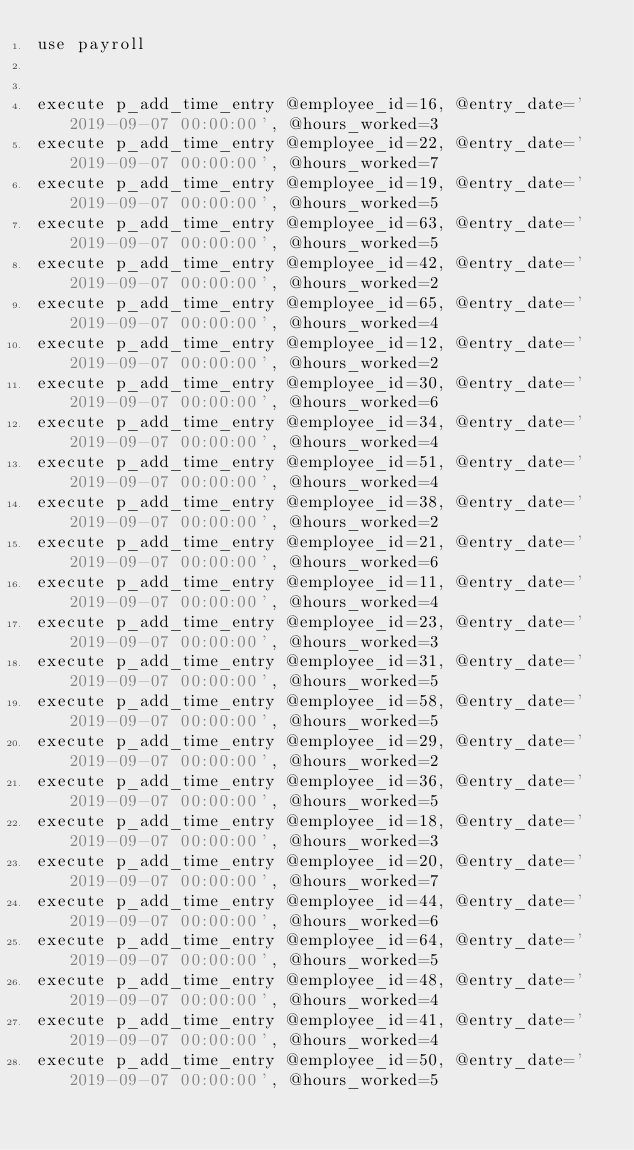<code> <loc_0><loc_0><loc_500><loc_500><_SQL_>use payroll


execute p_add_time_entry @employee_id=16, @entry_date='2019-09-07 00:00:00', @hours_worked=3
execute p_add_time_entry @employee_id=22, @entry_date='2019-09-07 00:00:00', @hours_worked=7
execute p_add_time_entry @employee_id=19, @entry_date='2019-09-07 00:00:00', @hours_worked=5
execute p_add_time_entry @employee_id=63, @entry_date='2019-09-07 00:00:00', @hours_worked=5
execute p_add_time_entry @employee_id=42, @entry_date='2019-09-07 00:00:00', @hours_worked=2
execute p_add_time_entry @employee_id=65, @entry_date='2019-09-07 00:00:00', @hours_worked=4
execute p_add_time_entry @employee_id=12, @entry_date='2019-09-07 00:00:00', @hours_worked=2
execute p_add_time_entry @employee_id=30, @entry_date='2019-09-07 00:00:00', @hours_worked=6
execute p_add_time_entry @employee_id=34, @entry_date='2019-09-07 00:00:00', @hours_worked=4
execute p_add_time_entry @employee_id=51, @entry_date='2019-09-07 00:00:00', @hours_worked=4
execute p_add_time_entry @employee_id=38, @entry_date='2019-09-07 00:00:00', @hours_worked=2
execute p_add_time_entry @employee_id=21, @entry_date='2019-09-07 00:00:00', @hours_worked=6
execute p_add_time_entry @employee_id=11, @entry_date='2019-09-07 00:00:00', @hours_worked=4
execute p_add_time_entry @employee_id=23, @entry_date='2019-09-07 00:00:00', @hours_worked=3
execute p_add_time_entry @employee_id=31, @entry_date='2019-09-07 00:00:00', @hours_worked=5
execute p_add_time_entry @employee_id=58, @entry_date='2019-09-07 00:00:00', @hours_worked=5
execute p_add_time_entry @employee_id=29, @entry_date='2019-09-07 00:00:00', @hours_worked=2
execute p_add_time_entry @employee_id=36, @entry_date='2019-09-07 00:00:00', @hours_worked=5
execute p_add_time_entry @employee_id=18, @entry_date='2019-09-07 00:00:00', @hours_worked=3
execute p_add_time_entry @employee_id=20, @entry_date='2019-09-07 00:00:00', @hours_worked=7
execute p_add_time_entry @employee_id=44, @entry_date='2019-09-07 00:00:00', @hours_worked=6
execute p_add_time_entry @employee_id=64, @entry_date='2019-09-07 00:00:00', @hours_worked=5
execute p_add_time_entry @employee_id=48, @entry_date='2019-09-07 00:00:00', @hours_worked=4
execute p_add_time_entry @employee_id=41, @entry_date='2019-09-07 00:00:00', @hours_worked=4
execute p_add_time_entry @employee_id=50, @entry_date='2019-09-07 00:00:00', @hours_worked=5

</code> 